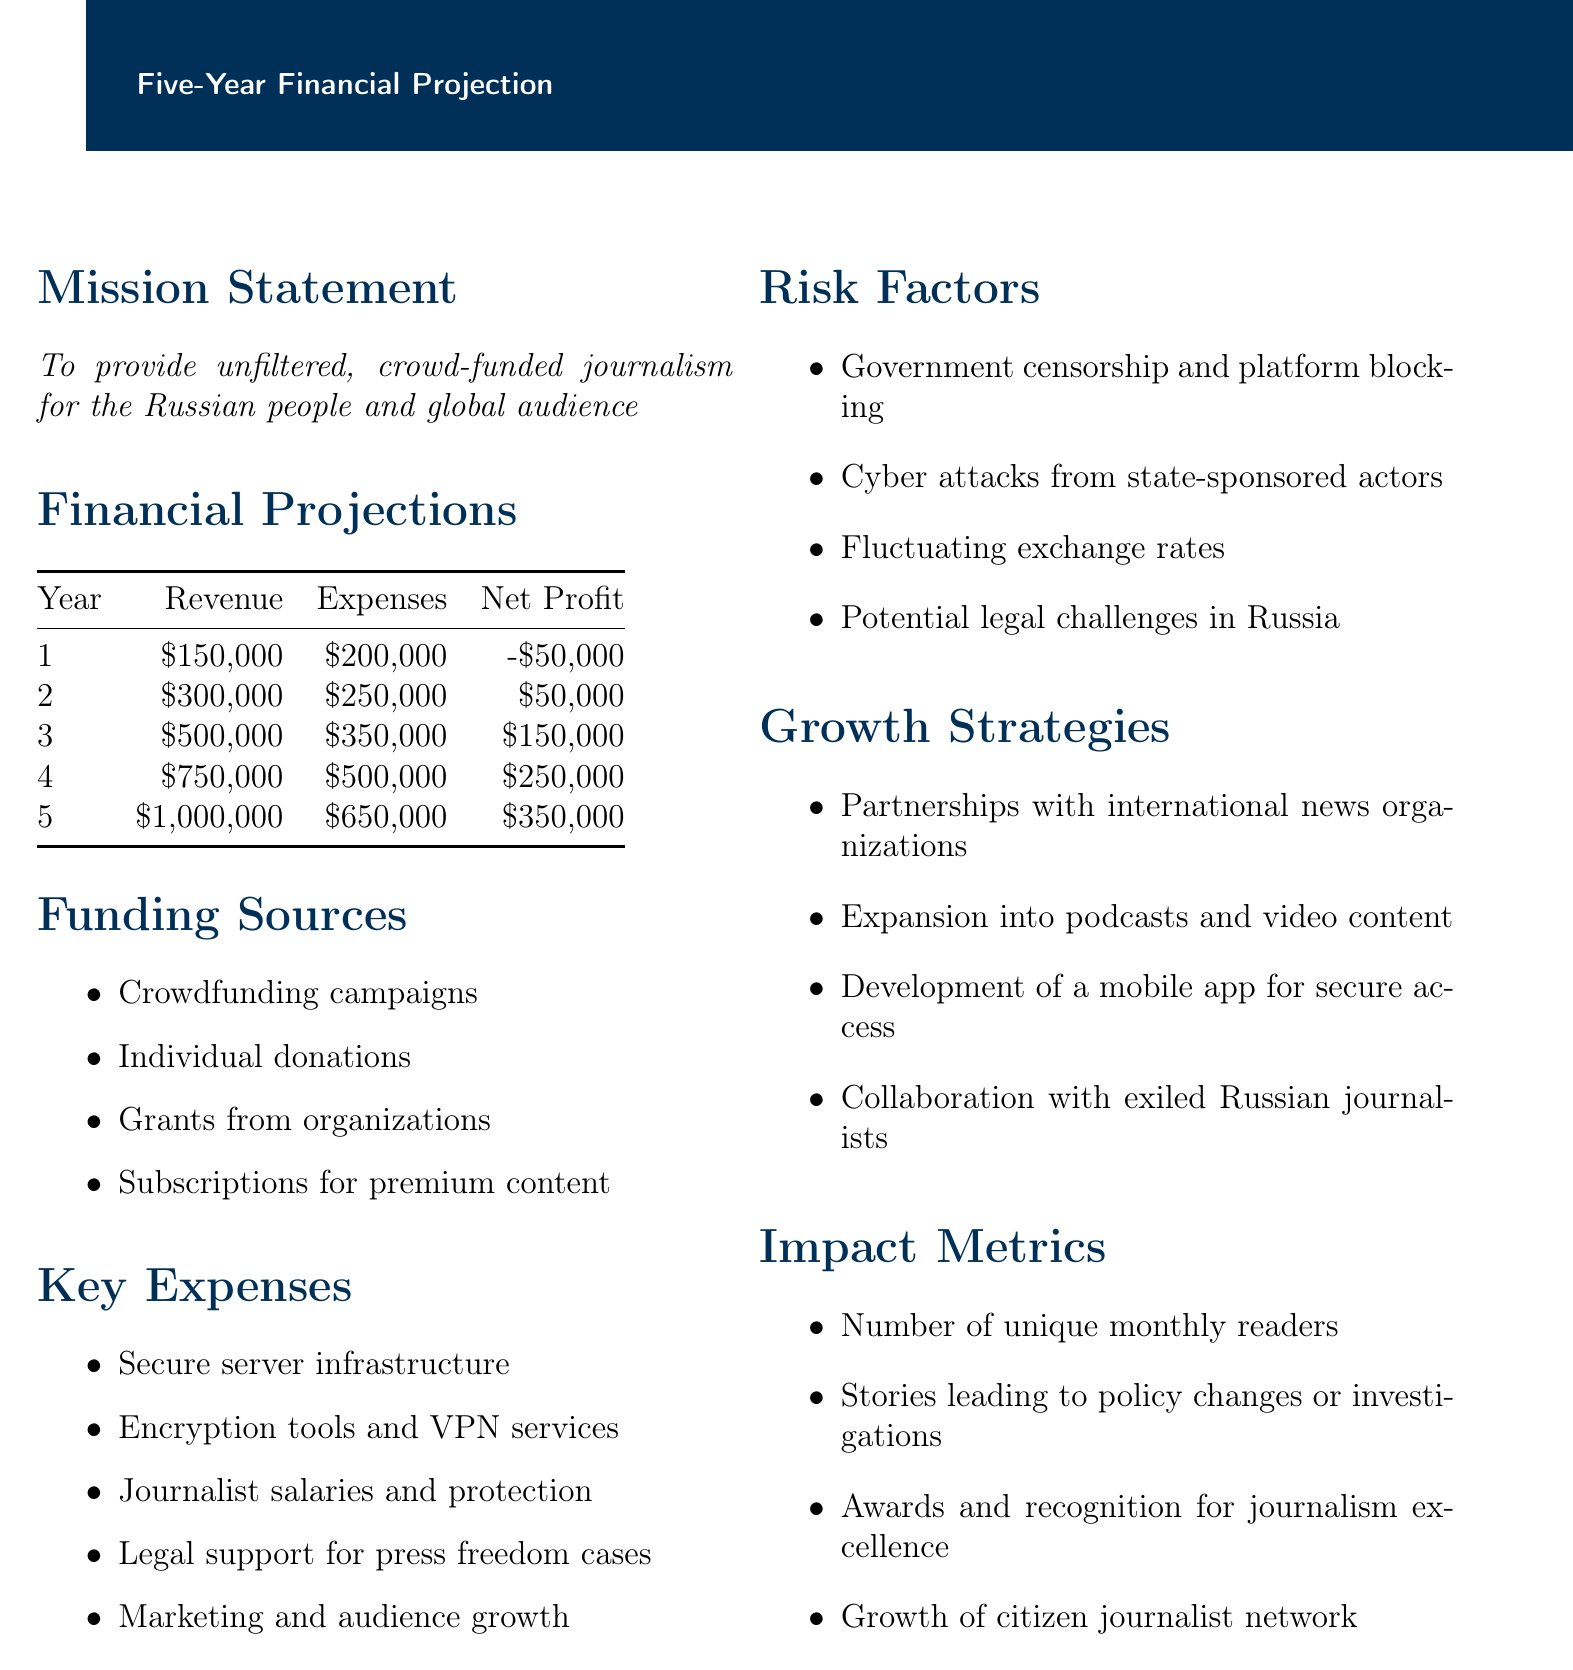What is the total revenue in year 5? The total revenue in year 5 is provided directly in the document as $1,000,000.
Answer: $1,000,000 What is the mission statement of TruthWave? The mission statement is explicitly mentioned in the document as to provide unfiltered, crowd-funded journalism for the Russian people and global audience.
Answer: To provide unfiltered, crowd-funded journalism for the Russian people and global audience What were the expenses in year 3? The expenses in year 3 are specified in the document as $350,000.
Answer: $350,000 What is the net profit for year 2? The document states the net profit for year 2 as $50,000.
Answer: $50,000 Which funding source is related to individual contributions? The funding source that pertains to individual contributions is mentioned as Individual donations.
Answer: Individual donations What are the risk factors listed? The document lists four risk factors including government censorship and potential platform blocking, cyber attacks from state-sponsored actors, fluctuating exchange rates, and potential legal challenges in Russia.
Answer: Government censorship and potential platform blocking, cyber attacks from state-sponsored actors, fluctuating exchange rates, potential legal challenges in Russia What growth strategy involves collaborating with journalists outside Russia? The growth strategy involving collaboration with journalists outside Russia is Collaboration with exiled Russian journalists, as stated in the document.
Answer: Collaboration with exiled Russian journalists How many years show a net profit in the projections? The projections show net profit for 4 out of the 5 years.
Answer: 4 What impact metric focuses on audience engagement? The impact metric focusing on audience engagement is the Number of unique monthly readers.
Answer: Number of unique monthly readers 